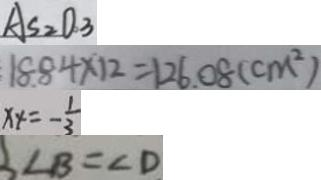Convert formula to latex. <formula><loc_0><loc_0><loc_500><loc_500>A S _ { 2 } O _ { 3 } 
 1 8 . 8 4 \times 1 2 = 1 2 6 . 0 8 ( c m ^ { 2 } ) 
 x _ { 4 } = - \frac { 1 } { 3 } 
 \angle B = \angle D</formula> 